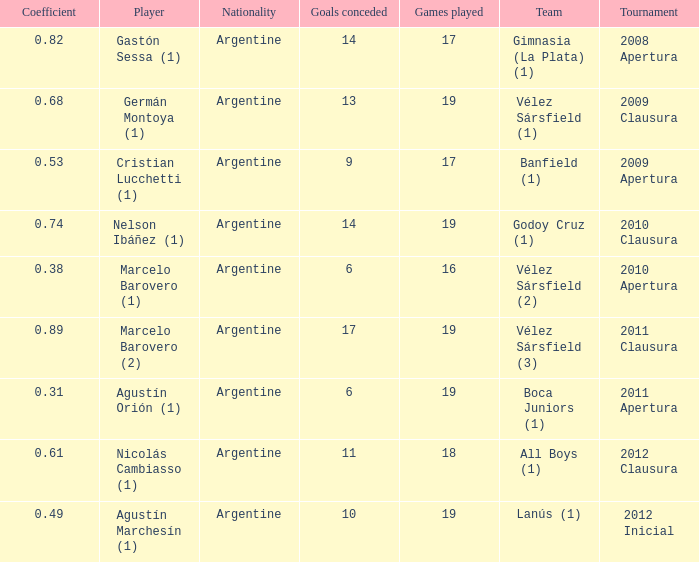Which team was in the 2012 clausura tournament? All Boys (1). 